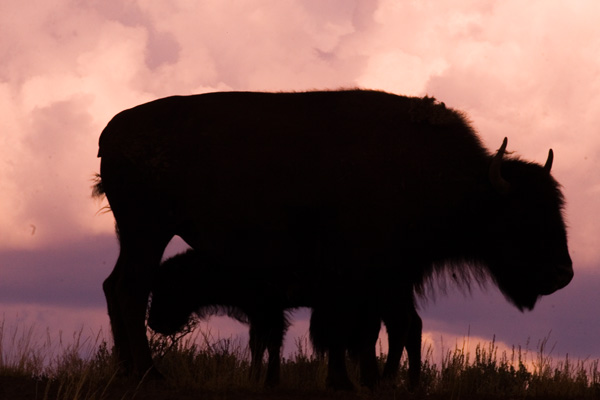What time of day does this image depict? The warm hues in the sky and the silhouette suggest that this image was taken at either dawn or dusk, which are known for their vibrant and colorful skies. 